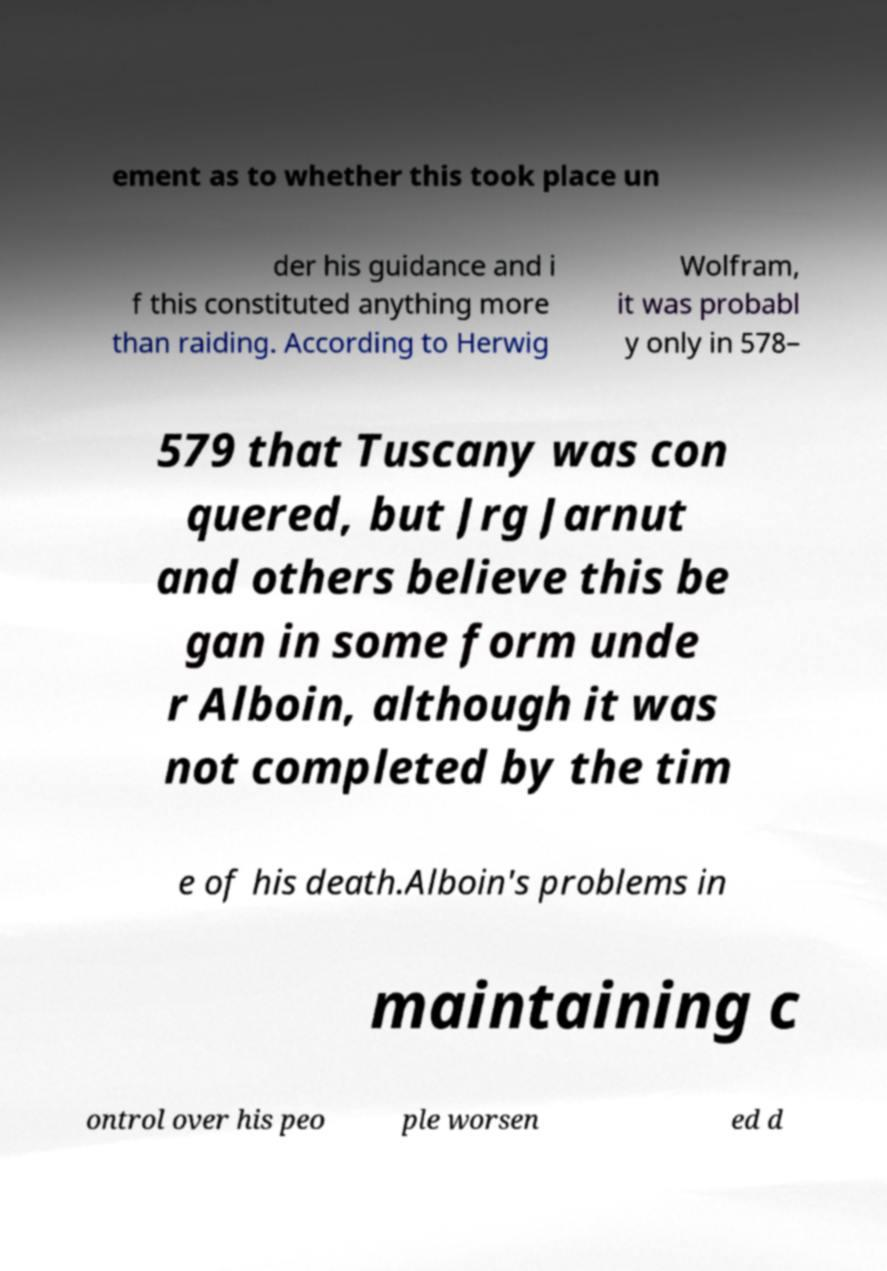I need the written content from this picture converted into text. Can you do that? ement as to whether this took place un der his guidance and i f this constituted anything more than raiding. According to Herwig Wolfram, it was probabl y only in 578– 579 that Tuscany was con quered, but Jrg Jarnut and others believe this be gan in some form unde r Alboin, although it was not completed by the tim e of his death.Alboin's problems in maintaining c ontrol over his peo ple worsen ed d 